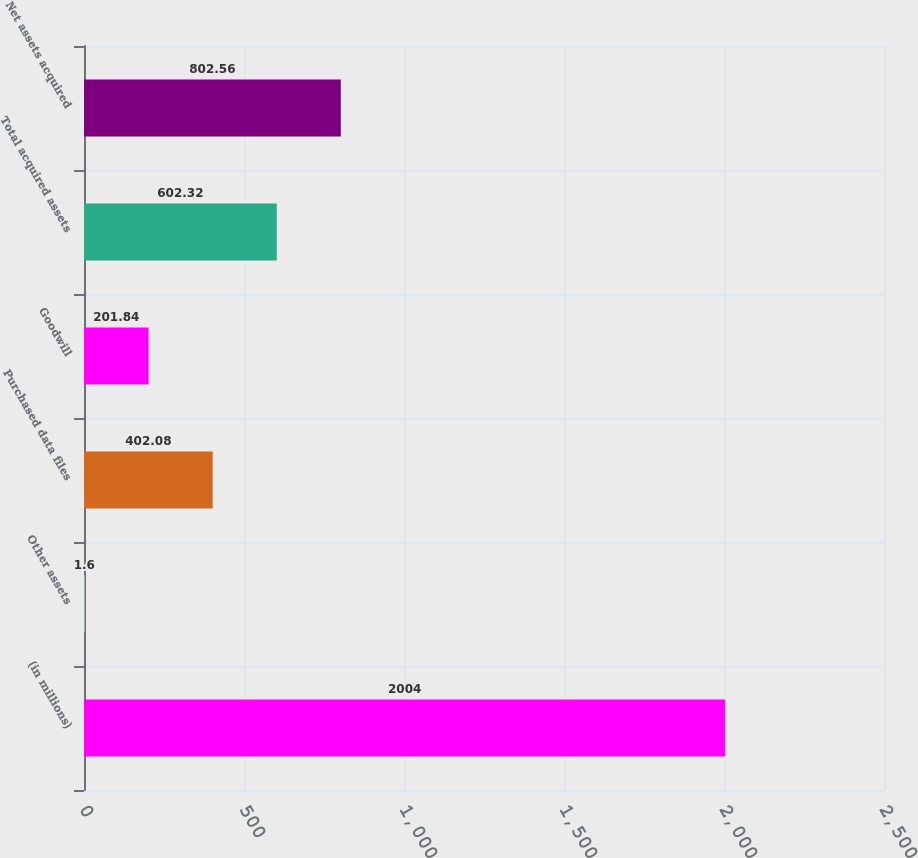Convert chart. <chart><loc_0><loc_0><loc_500><loc_500><bar_chart><fcel>(in millions)<fcel>Other assets<fcel>Purchased data files<fcel>Goodwill<fcel>Total acquired assets<fcel>Net assets acquired<nl><fcel>2004<fcel>1.6<fcel>402.08<fcel>201.84<fcel>602.32<fcel>802.56<nl></chart> 